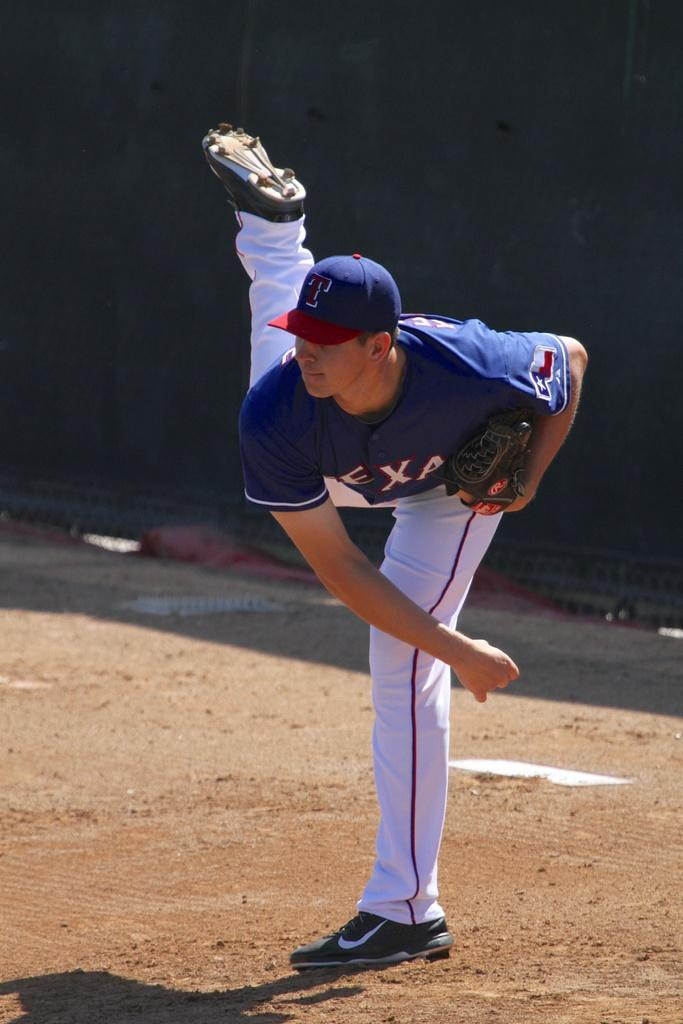<image>
Share a concise interpretation of the image provided. The player on the pitch wears the letter T on his hat. 